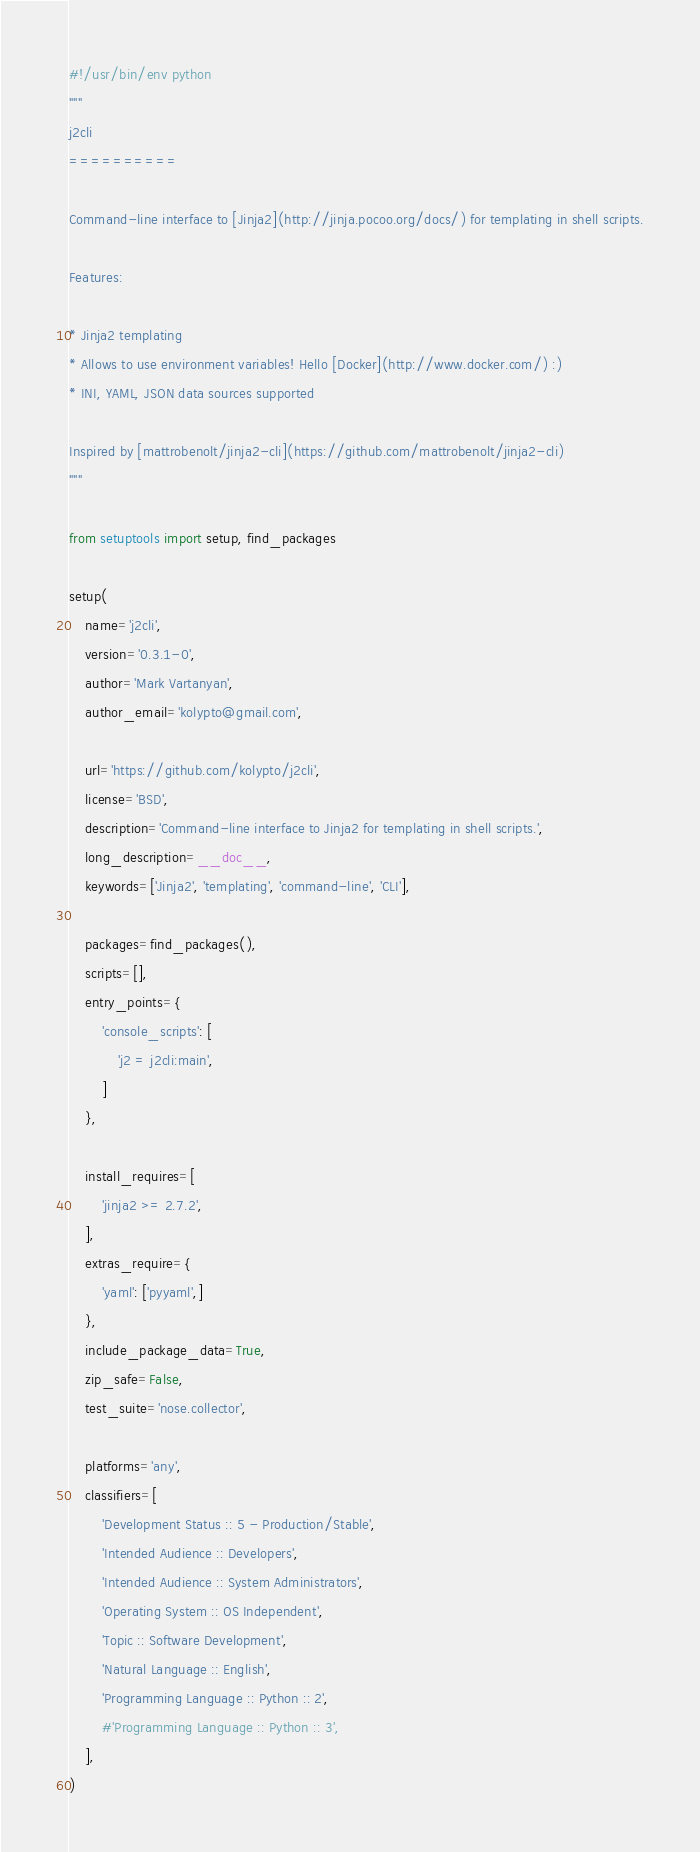<code> <loc_0><loc_0><loc_500><loc_500><_Python_>#!/usr/bin/env python
"""
j2cli
==========

Command-line interface to [Jinja2](http://jinja.pocoo.org/docs/) for templating in shell scripts.

Features:

* Jinja2 templating
* Allows to use environment variables! Hello [Docker](http://www.docker.com/) :)
* INI, YAML, JSON data sources supported

Inspired by [mattrobenolt/jinja2-cli](https://github.com/mattrobenolt/jinja2-cli)
"""

from setuptools import setup, find_packages

setup(
    name='j2cli',
    version='0.3.1-0',
    author='Mark Vartanyan',
    author_email='kolypto@gmail.com',

    url='https://github.com/kolypto/j2cli',
    license='BSD',
    description='Command-line interface to Jinja2 for templating in shell scripts.',
    long_description=__doc__,
    keywords=['Jinja2', 'templating', 'command-line', 'CLI'],

    packages=find_packages(),
    scripts=[],
    entry_points={
        'console_scripts': [
            'j2 = j2cli:main',
        ]
    },

    install_requires=[
        'jinja2 >= 2.7.2',
    ],
    extras_require={
        'yaml': ['pyyaml',]
    },
    include_package_data=True,
    zip_safe=False,
    test_suite='nose.collector',

    platforms='any',
    classifiers=[
        'Development Status :: 5 - Production/Stable',
        'Intended Audience :: Developers',
        'Intended Audience :: System Administrators',
        'Operating System :: OS Independent',
        'Topic :: Software Development',
        'Natural Language :: English',
        'Programming Language :: Python :: 2',
        #'Programming Language :: Python :: 3',
    ],
)
</code> 